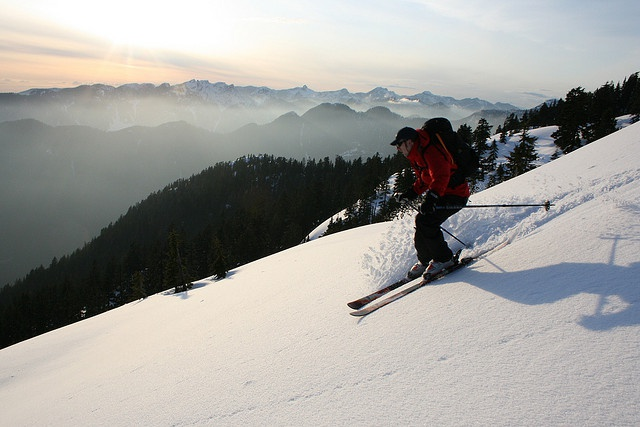Describe the objects in this image and their specific colors. I can see people in ivory, black, maroon, darkgray, and gray tones, backpack in ivory, black, maroon, and gray tones, and skis in ivory, black, gray, darkgray, and maroon tones in this image. 